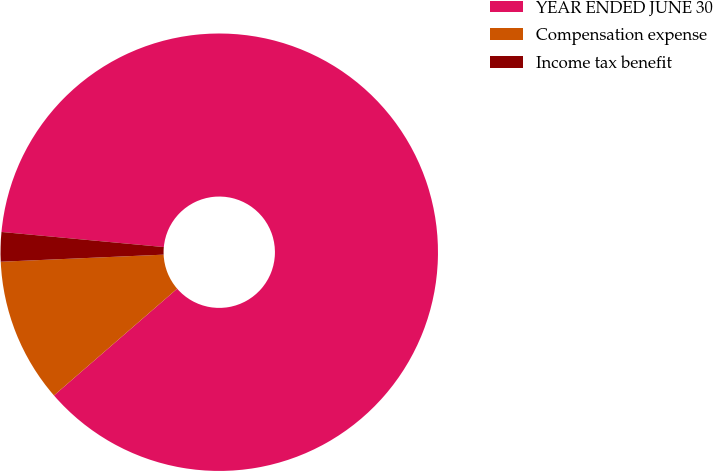Convert chart. <chart><loc_0><loc_0><loc_500><loc_500><pie_chart><fcel>YEAR ENDED JUNE 30<fcel>Compensation expense<fcel>Income tax benefit<nl><fcel>87.16%<fcel>10.67%<fcel>2.17%<nl></chart> 